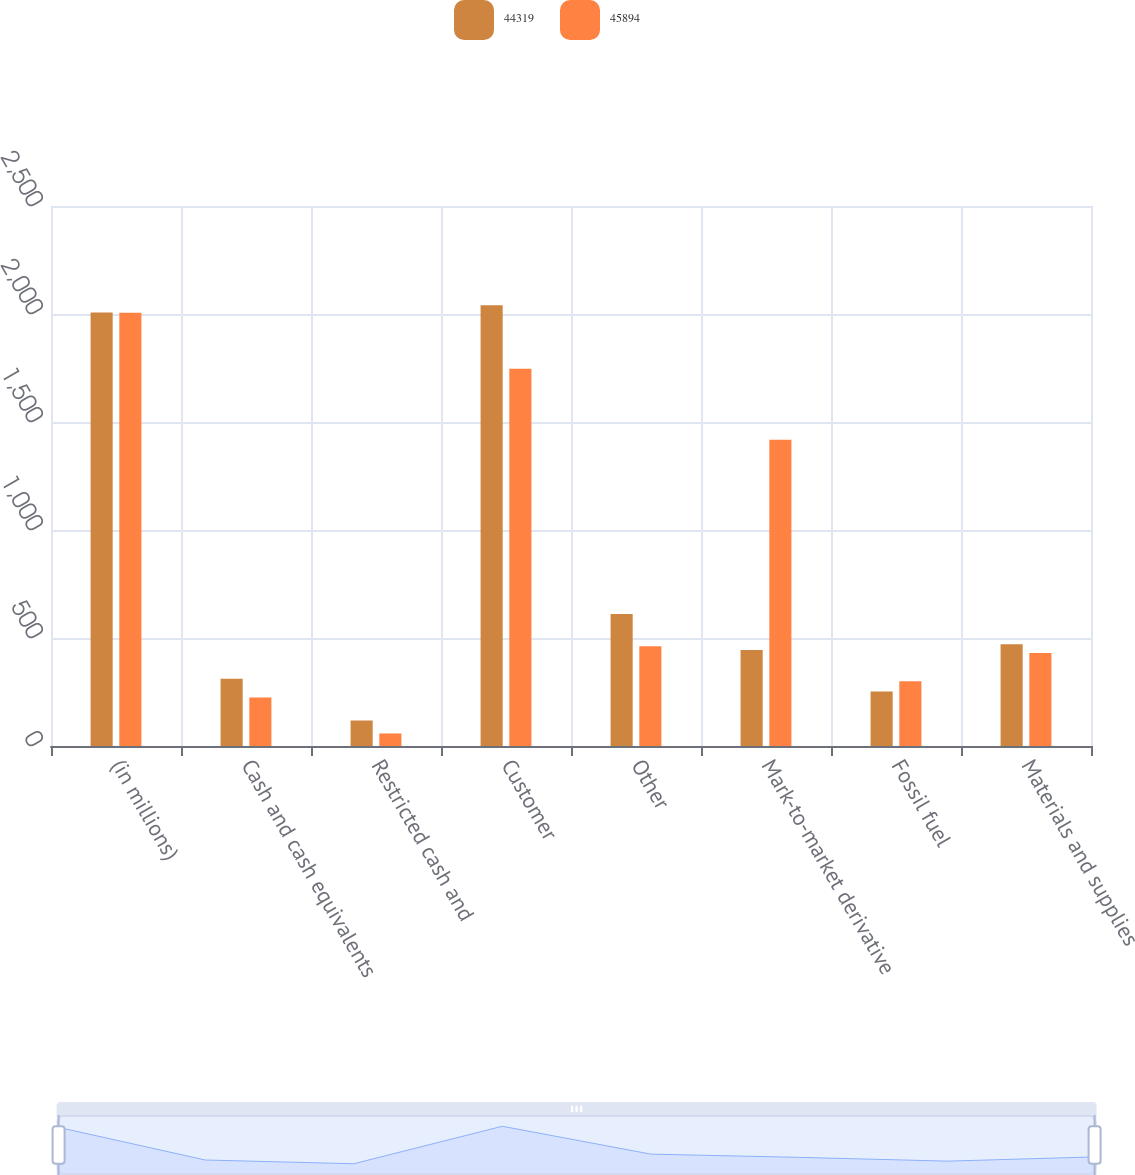<chart> <loc_0><loc_0><loc_500><loc_500><stacked_bar_chart><ecel><fcel>(in millions)<fcel>Cash and cash equivalents<fcel>Restricted cash and<fcel>Customer<fcel>Other<fcel>Mark-to-market derivative<fcel>Fossil fuel<fcel>Materials and supplies<nl><fcel>44319<fcel>2007<fcel>311<fcel>118<fcel>2041<fcel>611<fcel>445<fcel>252<fcel>471<nl><fcel>45894<fcel>2006<fcel>224<fcel>58<fcel>1747<fcel>462<fcel>1418<fcel>300<fcel>431<nl></chart> 